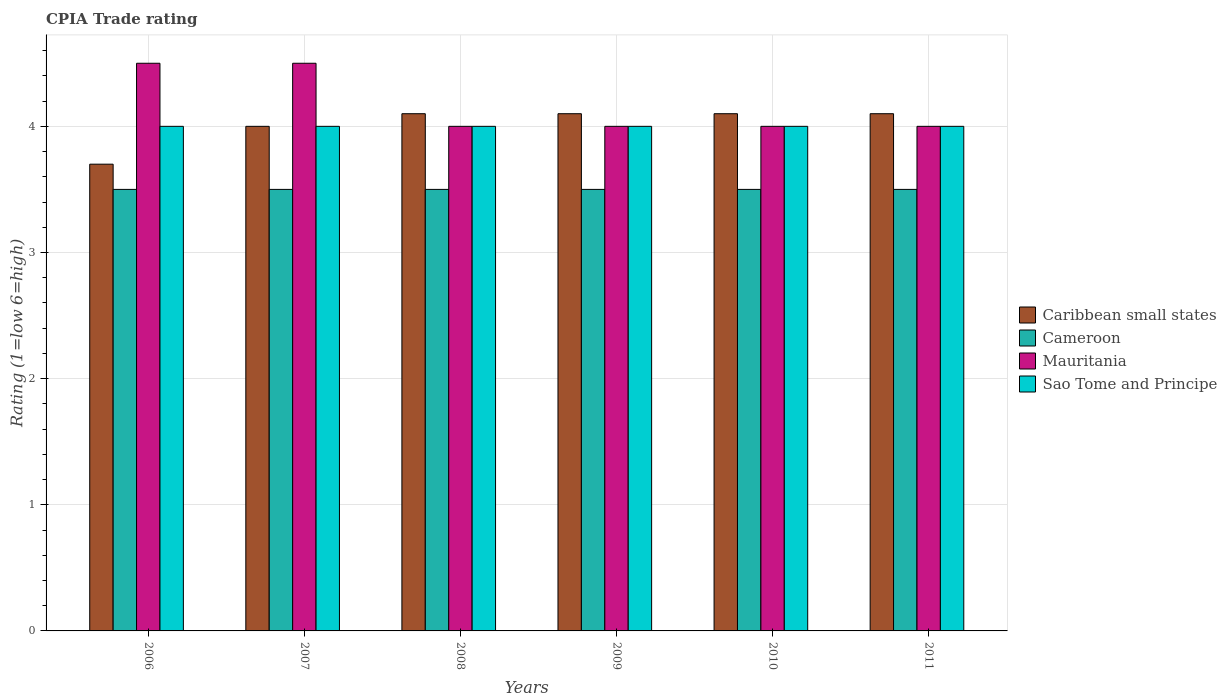Are the number of bars per tick equal to the number of legend labels?
Offer a terse response. Yes. What is the CPIA rating in Sao Tome and Principe in 2011?
Your answer should be compact. 4. Across all years, what is the maximum CPIA rating in Caribbean small states?
Provide a short and direct response. 4.1. Across all years, what is the minimum CPIA rating in Cameroon?
Give a very brief answer. 3.5. In which year was the CPIA rating in Caribbean small states minimum?
Provide a short and direct response. 2006. What is the difference between the CPIA rating in Sao Tome and Principe in 2007 and the CPIA rating in Mauritania in 2006?
Your answer should be compact. -0.5. What is the average CPIA rating in Sao Tome and Principe per year?
Make the answer very short. 4. What is the ratio of the CPIA rating in Mauritania in 2006 to that in 2008?
Offer a terse response. 1.12. Is the CPIA rating in Mauritania in 2006 less than that in 2010?
Give a very brief answer. No. In how many years, is the CPIA rating in Cameroon greater than the average CPIA rating in Cameroon taken over all years?
Give a very brief answer. 0. What does the 1st bar from the left in 2009 represents?
Provide a succinct answer. Caribbean small states. What does the 1st bar from the right in 2010 represents?
Offer a very short reply. Sao Tome and Principe. What is the difference between two consecutive major ticks on the Y-axis?
Your answer should be compact. 1. Does the graph contain grids?
Your answer should be very brief. Yes. Where does the legend appear in the graph?
Your answer should be compact. Center right. What is the title of the graph?
Ensure brevity in your answer.  CPIA Trade rating. What is the label or title of the X-axis?
Your answer should be very brief. Years. What is the Rating (1=low 6=high) in Mauritania in 2006?
Provide a succinct answer. 4.5. What is the Rating (1=low 6=high) in Sao Tome and Principe in 2006?
Your answer should be very brief. 4. What is the Rating (1=low 6=high) of Mauritania in 2007?
Keep it short and to the point. 4.5. What is the Rating (1=low 6=high) in Cameroon in 2008?
Give a very brief answer. 3.5. What is the Rating (1=low 6=high) of Mauritania in 2008?
Your response must be concise. 4. What is the Rating (1=low 6=high) of Sao Tome and Principe in 2008?
Give a very brief answer. 4. What is the Rating (1=low 6=high) of Sao Tome and Principe in 2009?
Make the answer very short. 4. What is the Rating (1=low 6=high) of Cameroon in 2010?
Your response must be concise. 3.5. What is the Rating (1=low 6=high) in Mauritania in 2010?
Make the answer very short. 4. What is the Rating (1=low 6=high) of Caribbean small states in 2011?
Keep it short and to the point. 4.1. What is the Rating (1=low 6=high) of Mauritania in 2011?
Keep it short and to the point. 4. What is the Rating (1=low 6=high) in Sao Tome and Principe in 2011?
Your answer should be compact. 4. Across all years, what is the maximum Rating (1=low 6=high) of Caribbean small states?
Offer a very short reply. 4.1. Across all years, what is the maximum Rating (1=low 6=high) of Mauritania?
Make the answer very short. 4.5. Across all years, what is the minimum Rating (1=low 6=high) in Caribbean small states?
Offer a terse response. 3.7. Across all years, what is the minimum Rating (1=low 6=high) of Cameroon?
Your response must be concise. 3.5. What is the total Rating (1=low 6=high) of Caribbean small states in the graph?
Your answer should be compact. 24.1. What is the total Rating (1=low 6=high) in Sao Tome and Principe in the graph?
Give a very brief answer. 24. What is the difference between the Rating (1=low 6=high) of Caribbean small states in 2006 and that in 2007?
Give a very brief answer. -0.3. What is the difference between the Rating (1=low 6=high) of Cameroon in 2006 and that in 2007?
Give a very brief answer. 0. What is the difference between the Rating (1=low 6=high) of Mauritania in 2006 and that in 2007?
Offer a very short reply. 0. What is the difference between the Rating (1=low 6=high) in Cameroon in 2006 and that in 2008?
Offer a terse response. 0. What is the difference between the Rating (1=low 6=high) of Mauritania in 2006 and that in 2008?
Provide a succinct answer. 0.5. What is the difference between the Rating (1=low 6=high) in Sao Tome and Principe in 2006 and that in 2008?
Your answer should be compact. 0. What is the difference between the Rating (1=low 6=high) in Cameroon in 2006 and that in 2009?
Your response must be concise. 0. What is the difference between the Rating (1=low 6=high) in Mauritania in 2006 and that in 2009?
Your response must be concise. 0.5. What is the difference between the Rating (1=low 6=high) of Sao Tome and Principe in 2006 and that in 2009?
Give a very brief answer. 0. What is the difference between the Rating (1=low 6=high) of Mauritania in 2006 and that in 2010?
Provide a succinct answer. 0.5. What is the difference between the Rating (1=low 6=high) of Caribbean small states in 2006 and that in 2011?
Offer a terse response. -0.4. What is the difference between the Rating (1=low 6=high) in Mauritania in 2006 and that in 2011?
Offer a terse response. 0.5. What is the difference between the Rating (1=low 6=high) of Mauritania in 2007 and that in 2008?
Your response must be concise. 0.5. What is the difference between the Rating (1=low 6=high) in Sao Tome and Principe in 2007 and that in 2008?
Ensure brevity in your answer.  0. What is the difference between the Rating (1=low 6=high) of Caribbean small states in 2007 and that in 2009?
Provide a short and direct response. -0.1. What is the difference between the Rating (1=low 6=high) of Mauritania in 2007 and that in 2009?
Provide a succinct answer. 0.5. What is the difference between the Rating (1=low 6=high) of Sao Tome and Principe in 2007 and that in 2009?
Offer a very short reply. 0. What is the difference between the Rating (1=low 6=high) of Mauritania in 2007 and that in 2010?
Keep it short and to the point. 0.5. What is the difference between the Rating (1=low 6=high) in Caribbean small states in 2007 and that in 2011?
Ensure brevity in your answer.  -0.1. What is the difference between the Rating (1=low 6=high) in Cameroon in 2007 and that in 2011?
Provide a short and direct response. 0. What is the difference between the Rating (1=low 6=high) of Sao Tome and Principe in 2007 and that in 2011?
Offer a terse response. 0. What is the difference between the Rating (1=low 6=high) of Mauritania in 2008 and that in 2009?
Offer a very short reply. 0. What is the difference between the Rating (1=low 6=high) of Sao Tome and Principe in 2008 and that in 2009?
Offer a terse response. 0. What is the difference between the Rating (1=low 6=high) in Caribbean small states in 2008 and that in 2010?
Ensure brevity in your answer.  0. What is the difference between the Rating (1=low 6=high) of Mauritania in 2008 and that in 2011?
Make the answer very short. 0. What is the difference between the Rating (1=low 6=high) of Sao Tome and Principe in 2008 and that in 2011?
Your answer should be very brief. 0. What is the difference between the Rating (1=low 6=high) of Sao Tome and Principe in 2009 and that in 2010?
Your response must be concise. 0. What is the difference between the Rating (1=low 6=high) of Caribbean small states in 2009 and that in 2011?
Provide a short and direct response. 0. What is the difference between the Rating (1=low 6=high) of Cameroon in 2009 and that in 2011?
Keep it short and to the point. 0. What is the difference between the Rating (1=low 6=high) in Mauritania in 2009 and that in 2011?
Make the answer very short. 0. What is the difference between the Rating (1=low 6=high) in Sao Tome and Principe in 2009 and that in 2011?
Ensure brevity in your answer.  0. What is the difference between the Rating (1=low 6=high) in Caribbean small states in 2010 and that in 2011?
Provide a short and direct response. 0. What is the difference between the Rating (1=low 6=high) in Mauritania in 2010 and that in 2011?
Give a very brief answer. 0. What is the difference between the Rating (1=low 6=high) in Caribbean small states in 2006 and the Rating (1=low 6=high) in Cameroon in 2007?
Your response must be concise. 0.2. What is the difference between the Rating (1=low 6=high) in Cameroon in 2006 and the Rating (1=low 6=high) in Mauritania in 2007?
Keep it short and to the point. -1. What is the difference between the Rating (1=low 6=high) of Cameroon in 2006 and the Rating (1=low 6=high) of Sao Tome and Principe in 2007?
Provide a short and direct response. -0.5. What is the difference between the Rating (1=low 6=high) of Caribbean small states in 2006 and the Rating (1=low 6=high) of Mauritania in 2008?
Give a very brief answer. -0.3. What is the difference between the Rating (1=low 6=high) in Caribbean small states in 2006 and the Rating (1=low 6=high) in Sao Tome and Principe in 2008?
Ensure brevity in your answer.  -0.3. What is the difference between the Rating (1=low 6=high) of Mauritania in 2006 and the Rating (1=low 6=high) of Sao Tome and Principe in 2008?
Offer a terse response. 0.5. What is the difference between the Rating (1=low 6=high) of Cameroon in 2006 and the Rating (1=low 6=high) of Sao Tome and Principe in 2009?
Make the answer very short. -0.5. What is the difference between the Rating (1=low 6=high) of Mauritania in 2006 and the Rating (1=low 6=high) of Sao Tome and Principe in 2009?
Keep it short and to the point. 0.5. What is the difference between the Rating (1=low 6=high) of Caribbean small states in 2006 and the Rating (1=low 6=high) of Cameroon in 2010?
Give a very brief answer. 0.2. What is the difference between the Rating (1=low 6=high) in Caribbean small states in 2006 and the Rating (1=low 6=high) in Mauritania in 2010?
Give a very brief answer. -0.3. What is the difference between the Rating (1=low 6=high) in Caribbean small states in 2006 and the Rating (1=low 6=high) in Sao Tome and Principe in 2010?
Keep it short and to the point. -0.3. What is the difference between the Rating (1=low 6=high) in Cameroon in 2006 and the Rating (1=low 6=high) in Sao Tome and Principe in 2010?
Your response must be concise. -0.5. What is the difference between the Rating (1=low 6=high) in Mauritania in 2006 and the Rating (1=low 6=high) in Sao Tome and Principe in 2010?
Offer a very short reply. 0.5. What is the difference between the Rating (1=low 6=high) in Caribbean small states in 2006 and the Rating (1=low 6=high) in Mauritania in 2011?
Provide a succinct answer. -0.3. What is the difference between the Rating (1=low 6=high) of Caribbean small states in 2006 and the Rating (1=low 6=high) of Sao Tome and Principe in 2011?
Your answer should be very brief. -0.3. What is the difference between the Rating (1=low 6=high) of Cameroon in 2006 and the Rating (1=low 6=high) of Mauritania in 2011?
Your answer should be very brief. -0.5. What is the difference between the Rating (1=low 6=high) of Mauritania in 2006 and the Rating (1=low 6=high) of Sao Tome and Principe in 2011?
Offer a terse response. 0.5. What is the difference between the Rating (1=low 6=high) in Caribbean small states in 2007 and the Rating (1=low 6=high) in Cameroon in 2008?
Ensure brevity in your answer.  0.5. What is the difference between the Rating (1=low 6=high) in Caribbean small states in 2007 and the Rating (1=low 6=high) in Mauritania in 2009?
Provide a succinct answer. 0. What is the difference between the Rating (1=low 6=high) of Caribbean small states in 2007 and the Rating (1=low 6=high) of Sao Tome and Principe in 2009?
Give a very brief answer. 0. What is the difference between the Rating (1=low 6=high) in Cameroon in 2007 and the Rating (1=low 6=high) in Mauritania in 2009?
Offer a very short reply. -0.5. What is the difference between the Rating (1=low 6=high) in Cameroon in 2007 and the Rating (1=low 6=high) in Sao Tome and Principe in 2009?
Your answer should be very brief. -0.5. What is the difference between the Rating (1=low 6=high) in Caribbean small states in 2007 and the Rating (1=low 6=high) in Cameroon in 2010?
Your answer should be compact. 0.5. What is the difference between the Rating (1=low 6=high) in Caribbean small states in 2007 and the Rating (1=low 6=high) in Mauritania in 2010?
Your answer should be very brief. 0. What is the difference between the Rating (1=low 6=high) in Caribbean small states in 2007 and the Rating (1=low 6=high) in Sao Tome and Principe in 2010?
Offer a very short reply. 0. What is the difference between the Rating (1=low 6=high) in Cameroon in 2007 and the Rating (1=low 6=high) in Sao Tome and Principe in 2010?
Your answer should be compact. -0.5. What is the difference between the Rating (1=low 6=high) of Mauritania in 2007 and the Rating (1=low 6=high) of Sao Tome and Principe in 2010?
Your answer should be compact. 0.5. What is the difference between the Rating (1=low 6=high) of Caribbean small states in 2007 and the Rating (1=low 6=high) of Cameroon in 2011?
Your answer should be compact. 0.5. What is the difference between the Rating (1=low 6=high) in Cameroon in 2007 and the Rating (1=low 6=high) in Mauritania in 2011?
Your response must be concise. -0.5. What is the difference between the Rating (1=low 6=high) of Caribbean small states in 2008 and the Rating (1=low 6=high) of Sao Tome and Principe in 2009?
Your answer should be compact. 0.1. What is the difference between the Rating (1=low 6=high) of Cameroon in 2008 and the Rating (1=low 6=high) of Mauritania in 2009?
Make the answer very short. -0.5. What is the difference between the Rating (1=low 6=high) in Mauritania in 2008 and the Rating (1=low 6=high) in Sao Tome and Principe in 2009?
Give a very brief answer. 0. What is the difference between the Rating (1=low 6=high) in Caribbean small states in 2008 and the Rating (1=low 6=high) in Cameroon in 2010?
Make the answer very short. 0.6. What is the difference between the Rating (1=low 6=high) in Caribbean small states in 2008 and the Rating (1=low 6=high) in Sao Tome and Principe in 2010?
Provide a succinct answer. 0.1. What is the difference between the Rating (1=low 6=high) of Cameroon in 2008 and the Rating (1=low 6=high) of Mauritania in 2010?
Provide a short and direct response. -0.5. What is the difference between the Rating (1=low 6=high) in Cameroon in 2008 and the Rating (1=low 6=high) in Sao Tome and Principe in 2010?
Your answer should be compact. -0.5. What is the difference between the Rating (1=low 6=high) in Caribbean small states in 2008 and the Rating (1=low 6=high) in Sao Tome and Principe in 2011?
Provide a short and direct response. 0.1. What is the difference between the Rating (1=low 6=high) in Cameroon in 2008 and the Rating (1=low 6=high) in Mauritania in 2011?
Ensure brevity in your answer.  -0.5. What is the difference between the Rating (1=low 6=high) of Mauritania in 2008 and the Rating (1=low 6=high) of Sao Tome and Principe in 2011?
Your answer should be compact. 0. What is the difference between the Rating (1=low 6=high) in Caribbean small states in 2009 and the Rating (1=low 6=high) in Mauritania in 2010?
Your answer should be compact. 0.1. What is the difference between the Rating (1=low 6=high) of Caribbean small states in 2009 and the Rating (1=low 6=high) of Sao Tome and Principe in 2010?
Your answer should be compact. 0.1. What is the difference between the Rating (1=low 6=high) in Cameroon in 2009 and the Rating (1=low 6=high) in Sao Tome and Principe in 2010?
Keep it short and to the point. -0.5. What is the difference between the Rating (1=low 6=high) in Caribbean small states in 2009 and the Rating (1=low 6=high) in Mauritania in 2011?
Offer a terse response. 0.1. What is the difference between the Rating (1=low 6=high) of Caribbean small states in 2009 and the Rating (1=low 6=high) of Sao Tome and Principe in 2011?
Your response must be concise. 0.1. What is the difference between the Rating (1=low 6=high) of Cameroon in 2009 and the Rating (1=low 6=high) of Mauritania in 2011?
Provide a succinct answer. -0.5. What is the difference between the Rating (1=low 6=high) of Caribbean small states in 2010 and the Rating (1=low 6=high) of Mauritania in 2011?
Ensure brevity in your answer.  0.1. What is the difference between the Rating (1=low 6=high) of Cameroon in 2010 and the Rating (1=low 6=high) of Sao Tome and Principe in 2011?
Ensure brevity in your answer.  -0.5. What is the average Rating (1=low 6=high) of Caribbean small states per year?
Your answer should be very brief. 4.02. What is the average Rating (1=low 6=high) in Mauritania per year?
Your answer should be compact. 4.17. What is the average Rating (1=low 6=high) of Sao Tome and Principe per year?
Your answer should be compact. 4. In the year 2006, what is the difference between the Rating (1=low 6=high) of Caribbean small states and Rating (1=low 6=high) of Cameroon?
Give a very brief answer. 0.2. In the year 2006, what is the difference between the Rating (1=low 6=high) in Caribbean small states and Rating (1=low 6=high) in Sao Tome and Principe?
Keep it short and to the point. -0.3. In the year 2006, what is the difference between the Rating (1=low 6=high) in Cameroon and Rating (1=low 6=high) in Mauritania?
Offer a terse response. -1. In the year 2006, what is the difference between the Rating (1=low 6=high) in Cameroon and Rating (1=low 6=high) in Sao Tome and Principe?
Ensure brevity in your answer.  -0.5. In the year 2006, what is the difference between the Rating (1=low 6=high) in Mauritania and Rating (1=low 6=high) in Sao Tome and Principe?
Your answer should be very brief. 0.5. In the year 2007, what is the difference between the Rating (1=low 6=high) of Caribbean small states and Rating (1=low 6=high) of Cameroon?
Provide a short and direct response. 0.5. In the year 2007, what is the difference between the Rating (1=low 6=high) of Cameroon and Rating (1=low 6=high) of Sao Tome and Principe?
Provide a short and direct response. -0.5. In the year 2007, what is the difference between the Rating (1=low 6=high) in Mauritania and Rating (1=low 6=high) in Sao Tome and Principe?
Make the answer very short. 0.5. In the year 2009, what is the difference between the Rating (1=low 6=high) in Caribbean small states and Rating (1=low 6=high) in Cameroon?
Provide a succinct answer. 0.6. In the year 2009, what is the difference between the Rating (1=low 6=high) in Caribbean small states and Rating (1=low 6=high) in Sao Tome and Principe?
Ensure brevity in your answer.  0.1. In the year 2009, what is the difference between the Rating (1=low 6=high) of Cameroon and Rating (1=low 6=high) of Mauritania?
Your answer should be compact. -0.5. In the year 2010, what is the difference between the Rating (1=low 6=high) in Caribbean small states and Rating (1=low 6=high) in Mauritania?
Ensure brevity in your answer.  0.1. In the year 2010, what is the difference between the Rating (1=low 6=high) in Caribbean small states and Rating (1=low 6=high) in Sao Tome and Principe?
Keep it short and to the point. 0.1. In the year 2010, what is the difference between the Rating (1=low 6=high) of Cameroon and Rating (1=low 6=high) of Mauritania?
Provide a short and direct response. -0.5. In the year 2010, what is the difference between the Rating (1=low 6=high) of Mauritania and Rating (1=low 6=high) of Sao Tome and Principe?
Give a very brief answer. 0. In the year 2011, what is the difference between the Rating (1=low 6=high) in Caribbean small states and Rating (1=low 6=high) in Mauritania?
Offer a terse response. 0.1. In the year 2011, what is the difference between the Rating (1=low 6=high) of Cameroon and Rating (1=low 6=high) of Mauritania?
Offer a very short reply. -0.5. In the year 2011, what is the difference between the Rating (1=low 6=high) of Mauritania and Rating (1=low 6=high) of Sao Tome and Principe?
Offer a terse response. 0. What is the ratio of the Rating (1=low 6=high) of Caribbean small states in 2006 to that in 2007?
Your answer should be very brief. 0.93. What is the ratio of the Rating (1=low 6=high) of Cameroon in 2006 to that in 2007?
Offer a very short reply. 1. What is the ratio of the Rating (1=low 6=high) of Mauritania in 2006 to that in 2007?
Provide a short and direct response. 1. What is the ratio of the Rating (1=low 6=high) of Caribbean small states in 2006 to that in 2008?
Make the answer very short. 0.9. What is the ratio of the Rating (1=low 6=high) in Mauritania in 2006 to that in 2008?
Offer a very short reply. 1.12. What is the ratio of the Rating (1=low 6=high) in Sao Tome and Principe in 2006 to that in 2008?
Your answer should be very brief. 1. What is the ratio of the Rating (1=low 6=high) of Caribbean small states in 2006 to that in 2009?
Your answer should be very brief. 0.9. What is the ratio of the Rating (1=low 6=high) in Cameroon in 2006 to that in 2009?
Provide a succinct answer. 1. What is the ratio of the Rating (1=low 6=high) of Mauritania in 2006 to that in 2009?
Ensure brevity in your answer.  1.12. What is the ratio of the Rating (1=low 6=high) of Caribbean small states in 2006 to that in 2010?
Offer a terse response. 0.9. What is the ratio of the Rating (1=low 6=high) in Cameroon in 2006 to that in 2010?
Your response must be concise. 1. What is the ratio of the Rating (1=low 6=high) of Mauritania in 2006 to that in 2010?
Make the answer very short. 1.12. What is the ratio of the Rating (1=low 6=high) of Caribbean small states in 2006 to that in 2011?
Your response must be concise. 0.9. What is the ratio of the Rating (1=low 6=high) in Cameroon in 2006 to that in 2011?
Give a very brief answer. 1. What is the ratio of the Rating (1=low 6=high) in Caribbean small states in 2007 to that in 2008?
Provide a succinct answer. 0.98. What is the ratio of the Rating (1=low 6=high) in Cameroon in 2007 to that in 2008?
Make the answer very short. 1. What is the ratio of the Rating (1=low 6=high) of Sao Tome and Principe in 2007 to that in 2008?
Ensure brevity in your answer.  1. What is the ratio of the Rating (1=low 6=high) in Caribbean small states in 2007 to that in 2009?
Offer a very short reply. 0.98. What is the ratio of the Rating (1=low 6=high) of Cameroon in 2007 to that in 2009?
Provide a succinct answer. 1. What is the ratio of the Rating (1=low 6=high) of Mauritania in 2007 to that in 2009?
Keep it short and to the point. 1.12. What is the ratio of the Rating (1=low 6=high) of Sao Tome and Principe in 2007 to that in 2009?
Provide a succinct answer. 1. What is the ratio of the Rating (1=low 6=high) in Caribbean small states in 2007 to that in 2010?
Your response must be concise. 0.98. What is the ratio of the Rating (1=low 6=high) of Cameroon in 2007 to that in 2010?
Your response must be concise. 1. What is the ratio of the Rating (1=low 6=high) in Mauritania in 2007 to that in 2010?
Your response must be concise. 1.12. What is the ratio of the Rating (1=low 6=high) of Sao Tome and Principe in 2007 to that in 2010?
Offer a very short reply. 1. What is the ratio of the Rating (1=low 6=high) in Caribbean small states in 2007 to that in 2011?
Your answer should be compact. 0.98. What is the ratio of the Rating (1=low 6=high) in Cameroon in 2007 to that in 2011?
Provide a short and direct response. 1. What is the ratio of the Rating (1=low 6=high) of Sao Tome and Principe in 2007 to that in 2011?
Your answer should be very brief. 1. What is the ratio of the Rating (1=low 6=high) in Cameroon in 2008 to that in 2009?
Your answer should be compact. 1. What is the ratio of the Rating (1=low 6=high) in Caribbean small states in 2008 to that in 2010?
Give a very brief answer. 1. What is the ratio of the Rating (1=low 6=high) of Sao Tome and Principe in 2008 to that in 2010?
Your answer should be very brief. 1. What is the ratio of the Rating (1=low 6=high) in Cameroon in 2008 to that in 2011?
Make the answer very short. 1. What is the ratio of the Rating (1=low 6=high) of Mauritania in 2008 to that in 2011?
Provide a succinct answer. 1. What is the ratio of the Rating (1=low 6=high) in Caribbean small states in 2009 to that in 2011?
Your response must be concise. 1. What is the ratio of the Rating (1=low 6=high) in Cameroon in 2009 to that in 2011?
Ensure brevity in your answer.  1. What is the ratio of the Rating (1=low 6=high) in Sao Tome and Principe in 2009 to that in 2011?
Offer a very short reply. 1. What is the ratio of the Rating (1=low 6=high) of Caribbean small states in 2010 to that in 2011?
Your answer should be very brief. 1. What is the difference between the highest and the second highest Rating (1=low 6=high) in Cameroon?
Provide a succinct answer. 0. What is the difference between the highest and the second highest Rating (1=low 6=high) in Sao Tome and Principe?
Your response must be concise. 0. What is the difference between the highest and the lowest Rating (1=low 6=high) of Caribbean small states?
Make the answer very short. 0.4. What is the difference between the highest and the lowest Rating (1=low 6=high) in Cameroon?
Provide a succinct answer. 0. What is the difference between the highest and the lowest Rating (1=low 6=high) in Mauritania?
Keep it short and to the point. 0.5. What is the difference between the highest and the lowest Rating (1=low 6=high) in Sao Tome and Principe?
Provide a succinct answer. 0. 